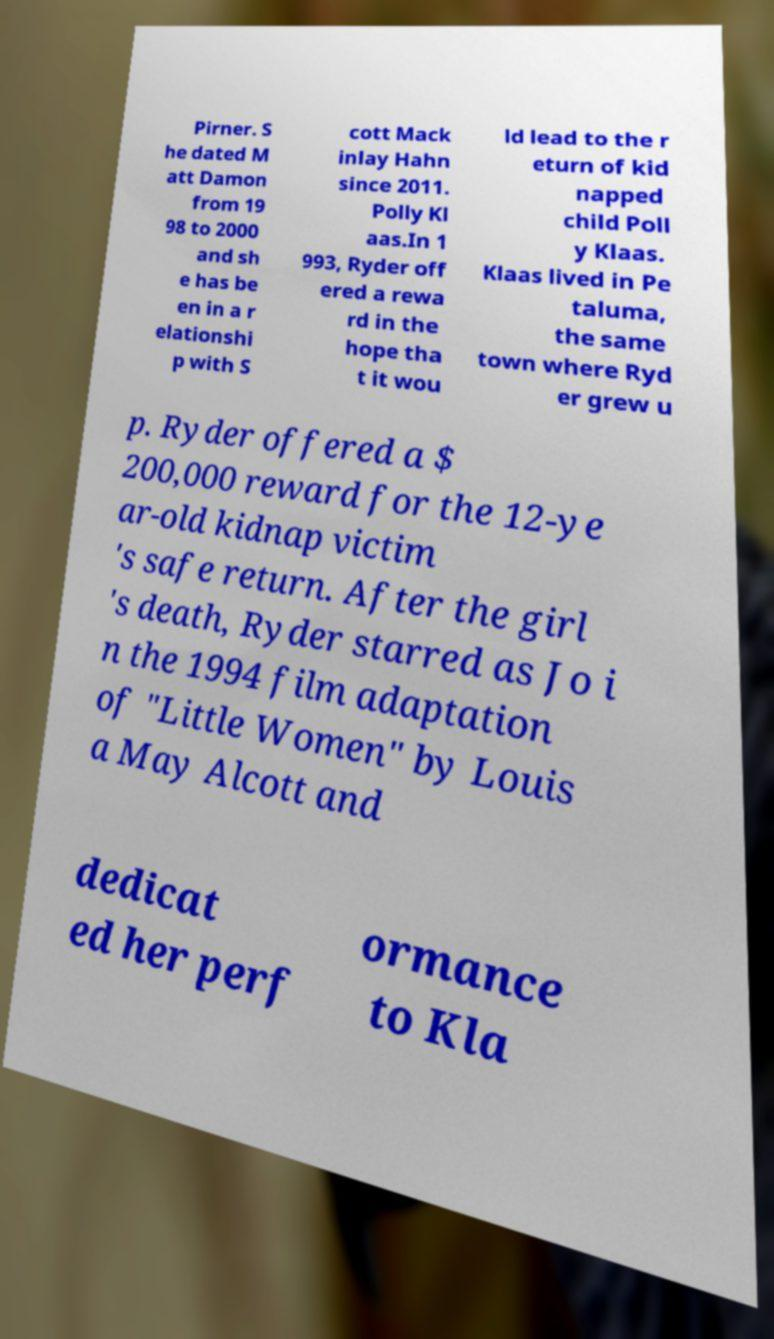Could you assist in decoding the text presented in this image and type it out clearly? Pirner. S he dated M att Damon from 19 98 to 2000 and sh e has be en in a r elationshi p with S cott Mack inlay Hahn since 2011. Polly Kl aas.In 1 993, Ryder off ered a rewa rd in the hope tha t it wou ld lead to the r eturn of kid napped child Poll y Klaas. Klaas lived in Pe taluma, the same town where Ryd er grew u p. Ryder offered a $ 200,000 reward for the 12-ye ar-old kidnap victim 's safe return. After the girl 's death, Ryder starred as Jo i n the 1994 film adaptation of "Little Women" by Louis a May Alcott and dedicat ed her perf ormance to Kla 